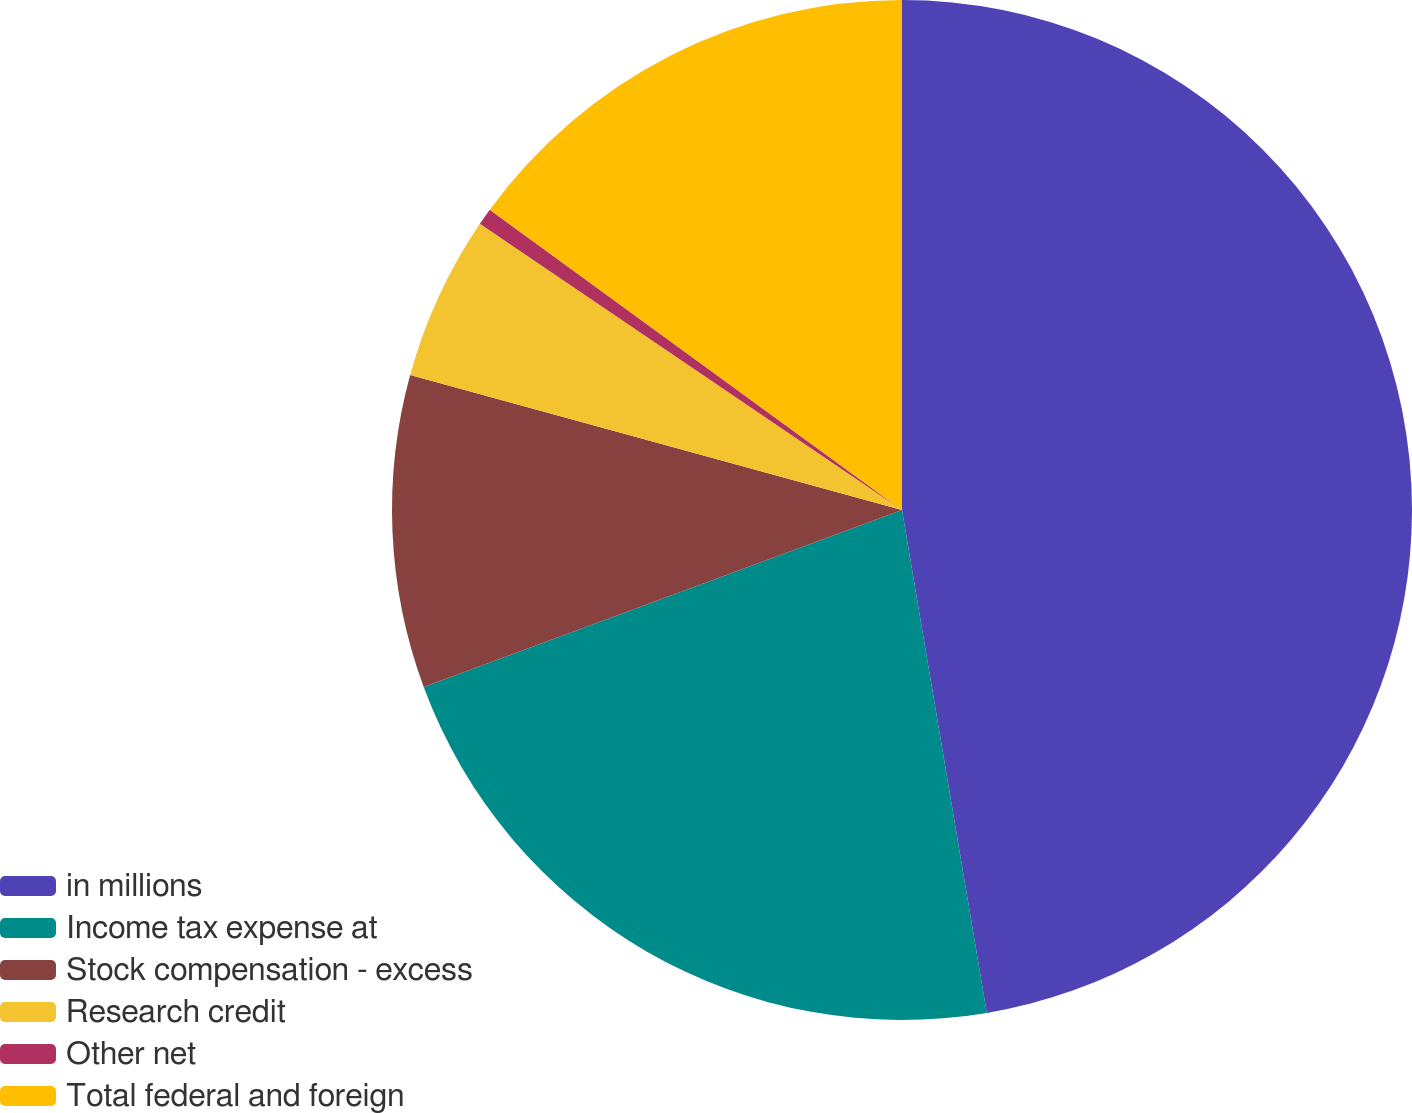Convert chart. <chart><loc_0><loc_0><loc_500><loc_500><pie_chart><fcel>in millions<fcel>Income tax expense at<fcel>Stock compensation - excess<fcel>Research credit<fcel>Other net<fcel>Total federal and foreign<nl><fcel>47.34%<fcel>22.02%<fcel>9.9%<fcel>5.22%<fcel>0.54%<fcel>14.98%<nl></chart> 